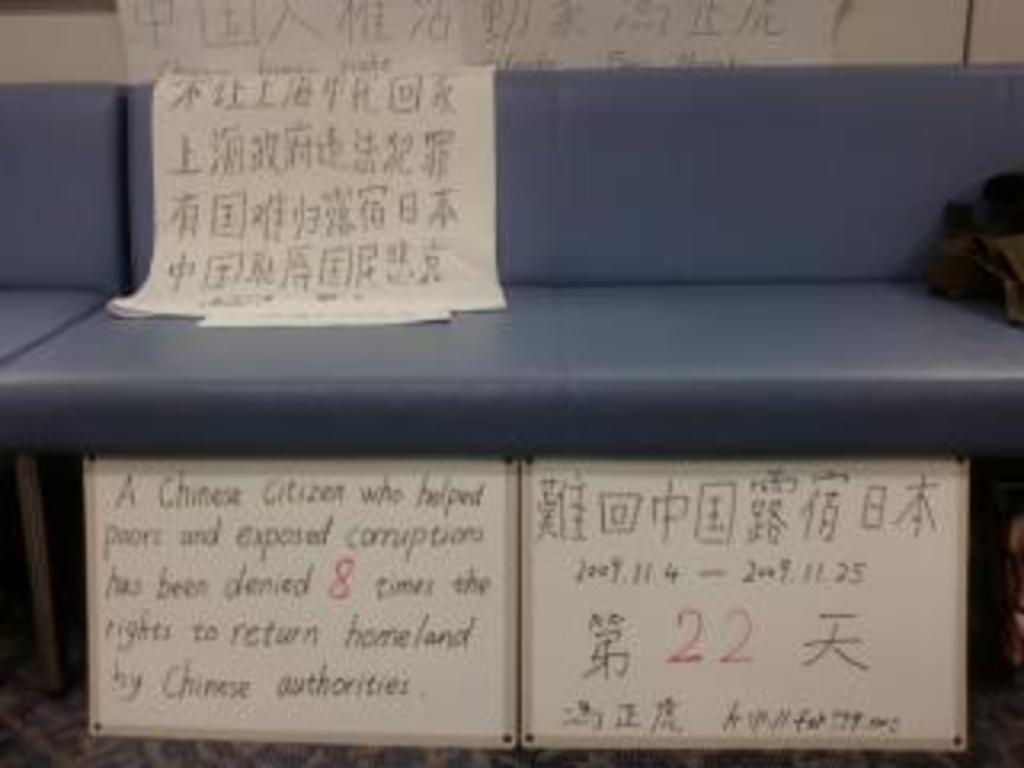What objects are in the foreground of the image? There are papers, boards, and a leather seat-like object in the foreground of the image. Can you describe the leather seat-like object? It appears to be a chair or a bench with a leather-like material. What is located on the right side of the image? There is a black object on the right side of the image. How many sheep can be seen grazing in the image? There are no sheep present in the image. Are there any boats visible in the image? There are no boats visible in the image. 